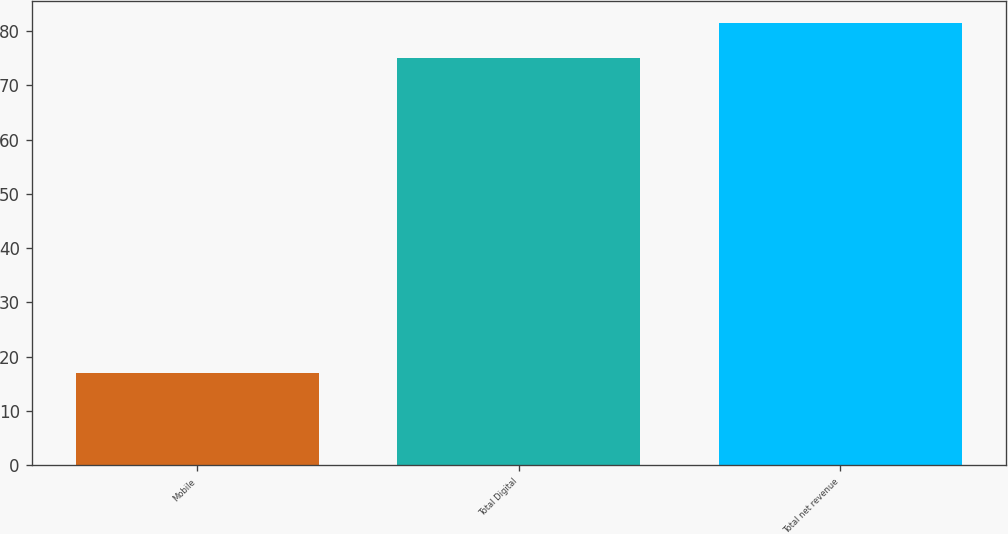Convert chart to OTSL. <chart><loc_0><loc_0><loc_500><loc_500><bar_chart><fcel>Mobile<fcel>Total Digital<fcel>Total net revenue<nl><fcel>17<fcel>75<fcel>81.4<nl></chart> 